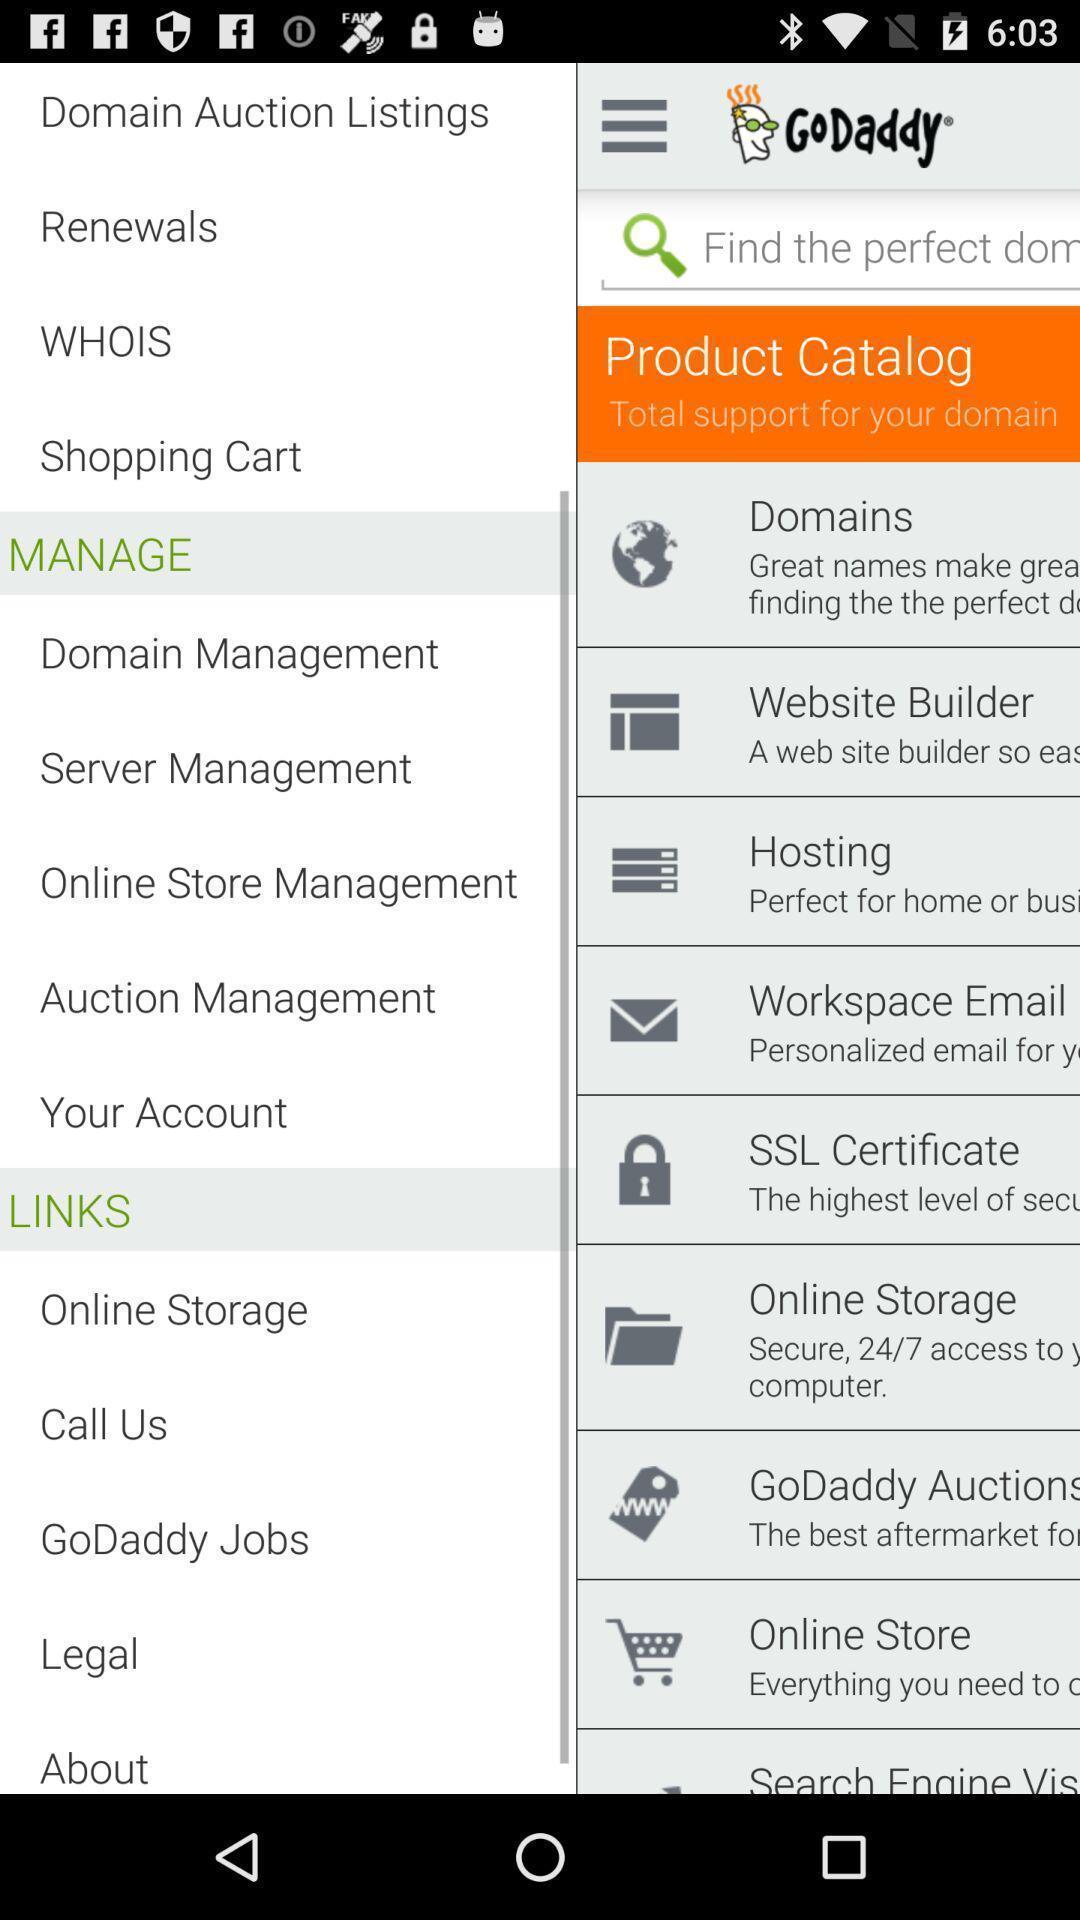Describe the key features of this screenshot. Pop up page showing various options in more menu. 